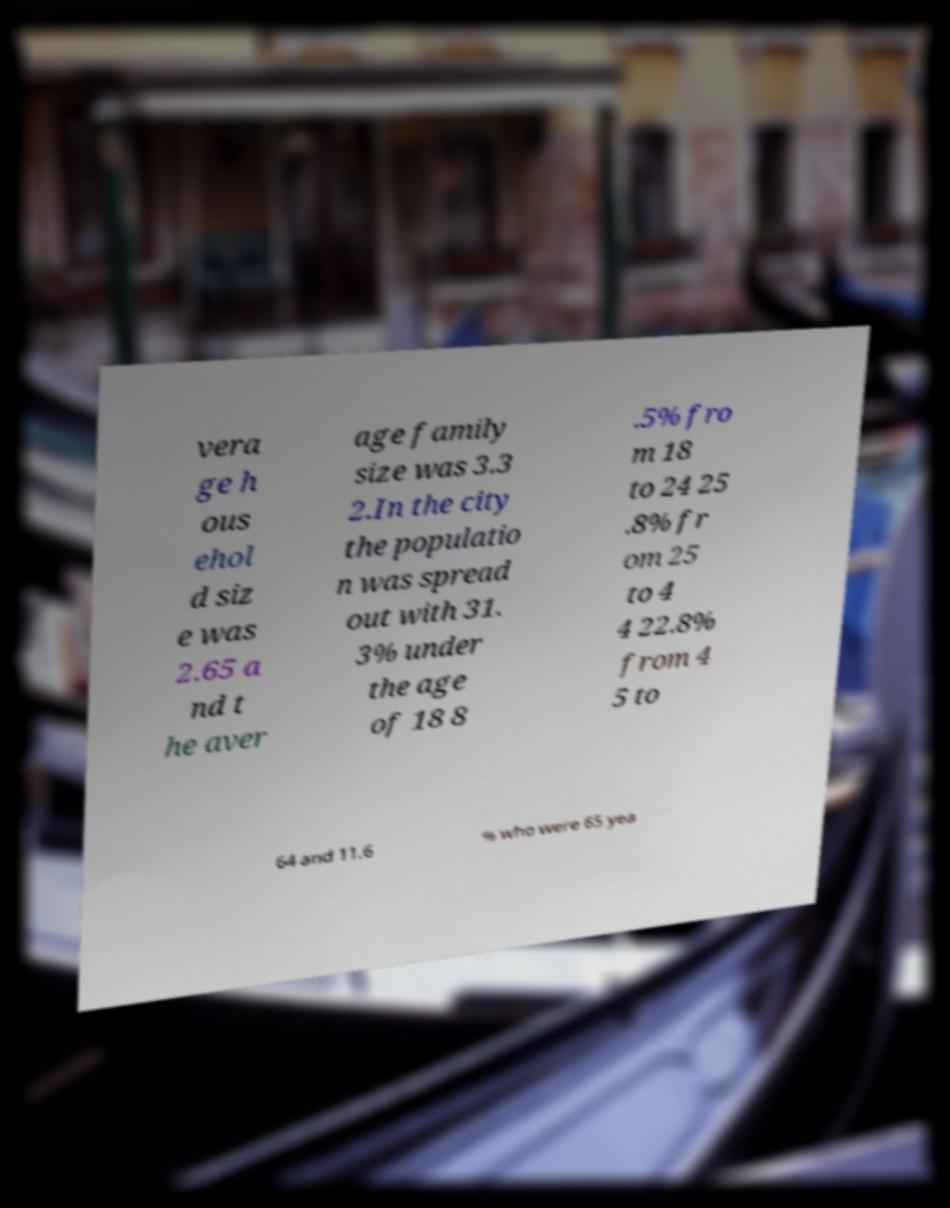Please read and relay the text visible in this image. What does it say? vera ge h ous ehol d siz e was 2.65 a nd t he aver age family size was 3.3 2.In the city the populatio n was spread out with 31. 3% under the age of 18 8 .5% fro m 18 to 24 25 .8% fr om 25 to 4 4 22.8% from 4 5 to 64 and 11.6 % who were 65 yea 